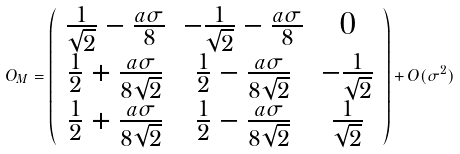<formula> <loc_0><loc_0><loc_500><loc_500>O _ { M } = \left ( \begin{array} { c c c } \frac { 1 } { \sqrt { 2 } } - \frac { a \sigma } { 8 } & - \frac { 1 } { \sqrt { 2 } } - \frac { a \sigma } { 8 } & 0 \\ \frac { 1 } { 2 } + \frac { a \sigma } { 8 \sqrt { 2 } } & \frac { 1 } { 2 } - \frac { a \sigma } { 8 \sqrt { 2 } } & - \frac { 1 } { \sqrt { 2 } } \\ \frac { 1 } { 2 } + \frac { a \sigma } { 8 \sqrt { 2 } } & \frac { 1 } { 2 } - \frac { a \sigma } { 8 \sqrt { 2 } } & \frac { 1 } { \sqrt { 2 } } \end{array} \right ) + O ( \sigma ^ { 2 } )</formula> 